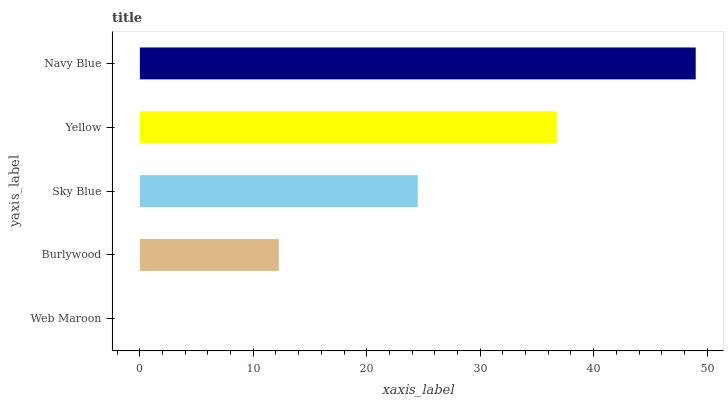Is Web Maroon the minimum?
Answer yes or no. Yes. Is Navy Blue the maximum?
Answer yes or no. Yes. Is Burlywood the minimum?
Answer yes or no. No. Is Burlywood the maximum?
Answer yes or no. No. Is Burlywood greater than Web Maroon?
Answer yes or no. Yes. Is Web Maroon less than Burlywood?
Answer yes or no. Yes. Is Web Maroon greater than Burlywood?
Answer yes or no. No. Is Burlywood less than Web Maroon?
Answer yes or no. No. Is Sky Blue the high median?
Answer yes or no. Yes. Is Sky Blue the low median?
Answer yes or no. Yes. Is Web Maroon the high median?
Answer yes or no. No. Is Web Maroon the low median?
Answer yes or no. No. 